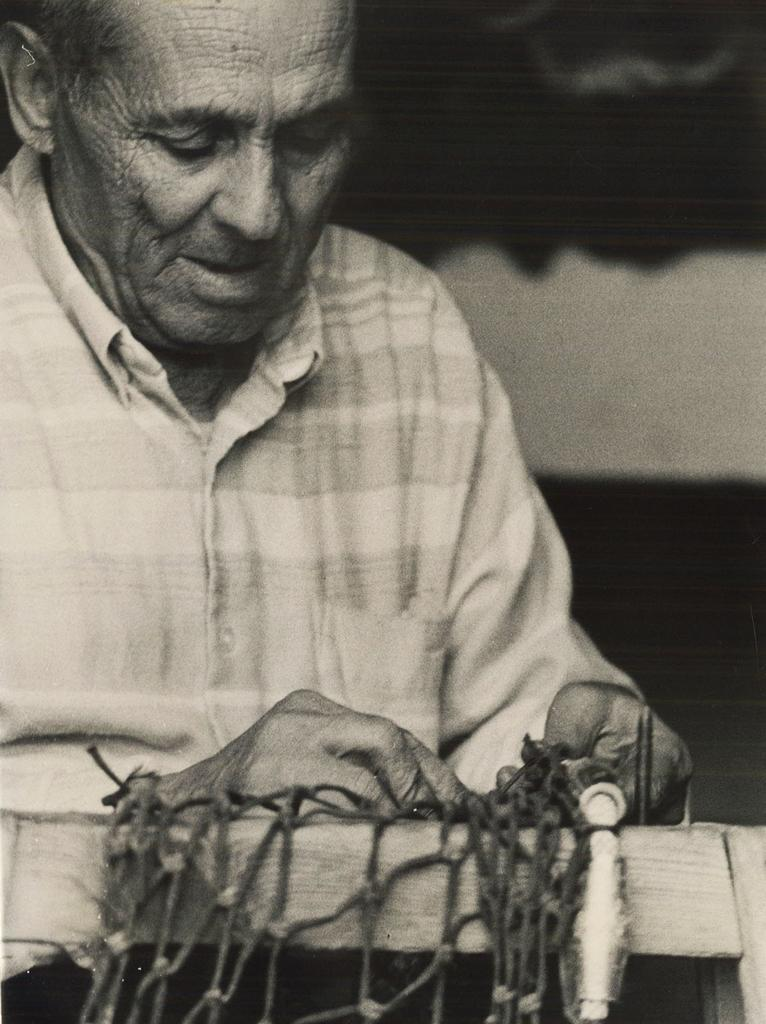What is the color scheme of the image? The image is black and white. Who is present in the image? There is a man in the image. What is the man doing in the image? The man is weaving. What can be seen at the bottom of the image? There are threads at the bottom of the image. What object is visible in the image? There is a wooden block in the image. How does the man use steam to help with his weaving in the image? There is no steam present in the image, and therefore it cannot be used to help with the weaving. 